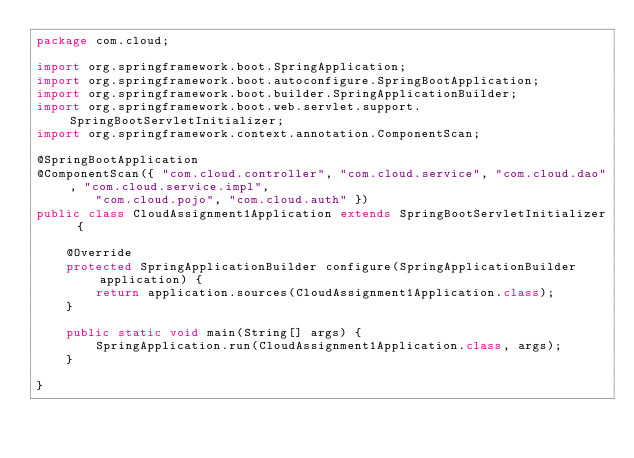Convert code to text. <code><loc_0><loc_0><loc_500><loc_500><_Java_>package com.cloud;

import org.springframework.boot.SpringApplication;
import org.springframework.boot.autoconfigure.SpringBootApplication;
import org.springframework.boot.builder.SpringApplicationBuilder;
import org.springframework.boot.web.servlet.support.SpringBootServletInitializer;
import org.springframework.context.annotation.ComponentScan;

@SpringBootApplication
@ComponentScan({ "com.cloud.controller", "com.cloud.service", "com.cloud.dao", "com.cloud.service.impl",
		"com.cloud.pojo", "com.cloud.auth" })
public class CloudAssignment1Application extends SpringBootServletInitializer {

	@Override
	protected SpringApplicationBuilder configure(SpringApplicationBuilder application) {
		return application.sources(CloudAssignment1Application.class);
	}

	public static void main(String[] args) {
		SpringApplication.run(CloudAssignment1Application.class, args);
	}

}
</code> 